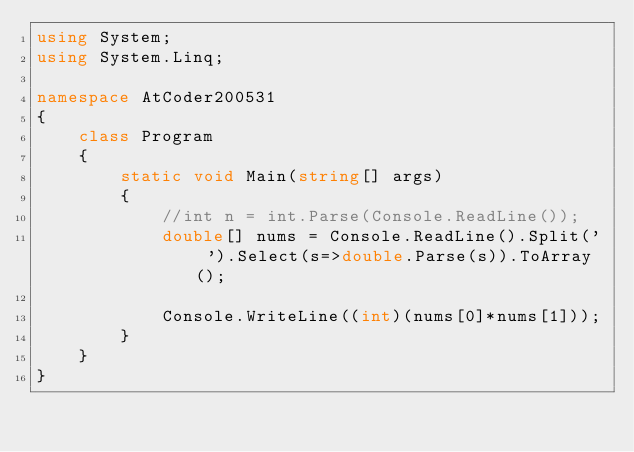<code> <loc_0><loc_0><loc_500><loc_500><_C#_>using System;
using System.Linq;

namespace AtCoder200531
{
    class Program
    {
        static void Main(string[] args)
        {
            //int n = int.Parse(Console.ReadLine());
            double[] nums = Console.ReadLine().Split(' ').Select(s=>double.Parse(s)).ToArray();

            Console.WriteLine((int)(nums[0]*nums[1]));
        }
    }
}
</code> 